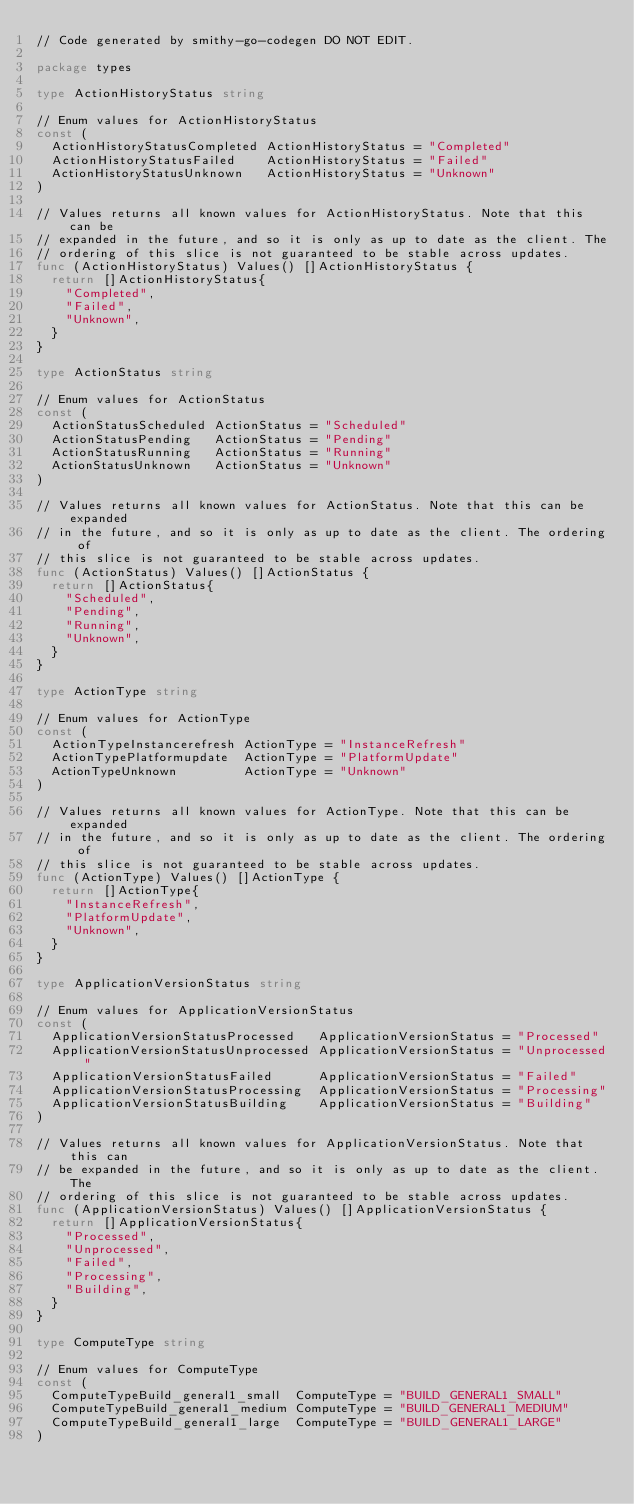<code> <loc_0><loc_0><loc_500><loc_500><_Go_>// Code generated by smithy-go-codegen DO NOT EDIT.

package types

type ActionHistoryStatus string

// Enum values for ActionHistoryStatus
const (
	ActionHistoryStatusCompleted ActionHistoryStatus = "Completed"
	ActionHistoryStatusFailed    ActionHistoryStatus = "Failed"
	ActionHistoryStatusUnknown   ActionHistoryStatus = "Unknown"
)

// Values returns all known values for ActionHistoryStatus. Note that this can be
// expanded in the future, and so it is only as up to date as the client. The
// ordering of this slice is not guaranteed to be stable across updates.
func (ActionHistoryStatus) Values() []ActionHistoryStatus {
	return []ActionHistoryStatus{
		"Completed",
		"Failed",
		"Unknown",
	}
}

type ActionStatus string

// Enum values for ActionStatus
const (
	ActionStatusScheduled ActionStatus = "Scheduled"
	ActionStatusPending   ActionStatus = "Pending"
	ActionStatusRunning   ActionStatus = "Running"
	ActionStatusUnknown   ActionStatus = "Unknown"
)

// Values returns all known values for ActionStatus. Note that this can be expanded
// in the future, and so it is only as up to date as the client. The ordering of
// this slice is not guaranteed to be stable across updates.
func (ActionStatus) Values() []ActionStatus {
	return []ActionStatus{
		"Scheduled",
		"Pending",
		"Running",
		"Unknown",
	}
}

type ActionType string

// Enum values for ActionType
const (
	ActionTypeInstancerefresh ActionType = "InstanceRefresh"
	ActionTypePlatformupdate  ActionType = "PlatformUpdate"
	ActionTypeUnknown         ActionType = "Unknown"
)

// Values returns all known values for ActionType. Note that this can be expanded
// in the future, and so it is only as up to date as the client. The ordering of
// this slice is not guaranteed to be stable across updates.
func (ActionType) Values() []ActionType {
	return []ActionType{
		"InstanceRefresh",
		"PlatformUpdate",
		"Unknown",
	}
}

type ApplicationVersionStatus string

// Enum values for ApplicationVersionStatus
const (
	ApplicationVersionStatusProcessed   ApplicationVersionStatus = "Processed"
	ApplicationVersionStatusUnprocessed ApplicationVersionStatus = "Unprocessed"
	ApplicationVersionStatusFailed      ApplicationVersionStatus = "Failed"
	ApplicationVersionStatusProcessing  ApplicationVersionStatus = "Processing"
	ApplicationVersionStatusBuilding    ApplicationVersionStatus = "Building"
)

// Values returns all known values for ApplicationVersionStatus. Note that this can
// be expanded in the future, and so it is only as up to date as the client. The
// ordering of this slice is not guaranteed to be stable across updates.
func (ApplicationVersionStatus) Values() []ApplicationVersionStatus {
	return []ApplicationVersionStatus{
		"Processed",
		"Unprocessed",
		"Failed",
		"Processing",
		"Building",
	}
}

type ComputeType string

// Enum values for ComputeType
const (
	ComputeTypeBuild_general1_small  ComputeType = "BUILD_GENERAL1_SMALL"
	ComputeTypeBuild_general1_medium ComputeType = "BUILD_GENERAL1_MEDIUM"
	ComputeTypeBuild_general1_large  ComputeType = "BUILD_GENERAL1_LARGE"
)
</code> 